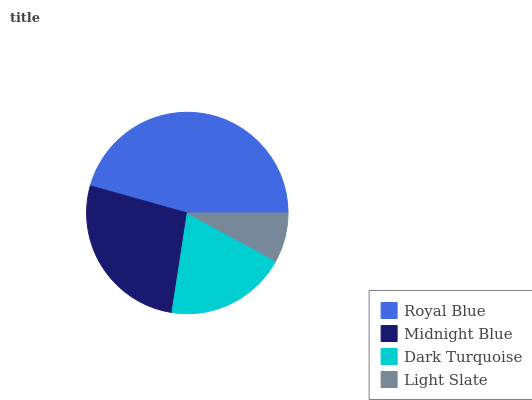Is Light Slate the minimum?
Answer yes or no. Yes. Is Royal Blue the maximum?
Answer yes or no. Yes. Is Midnight Blue the minimum?
Answer yes or no. No. Is Midnight Blue the maximum?
Answer yes or no. No. Is Royal Blue greater than Midnight Blue?
Answer yes or no. Yes. Is Midnight Blue less than Royal Blue?
Answer yes or no. Yes. Is Midnight Blue greater than Royal Blue?
Answer yes or no. No. Is Royal Blue less than Midnight Blue?
Answer yes or no. No. Is Midnight Blue the high median?
Answer yes or no. Yes. Is Dark Turquoise the low median?
Answer yes or no. Yes. Is Dark Turquoise the high median?
Answer yes or no. No. Is Midnight Blue the low median?
Answer yes or no. No. 